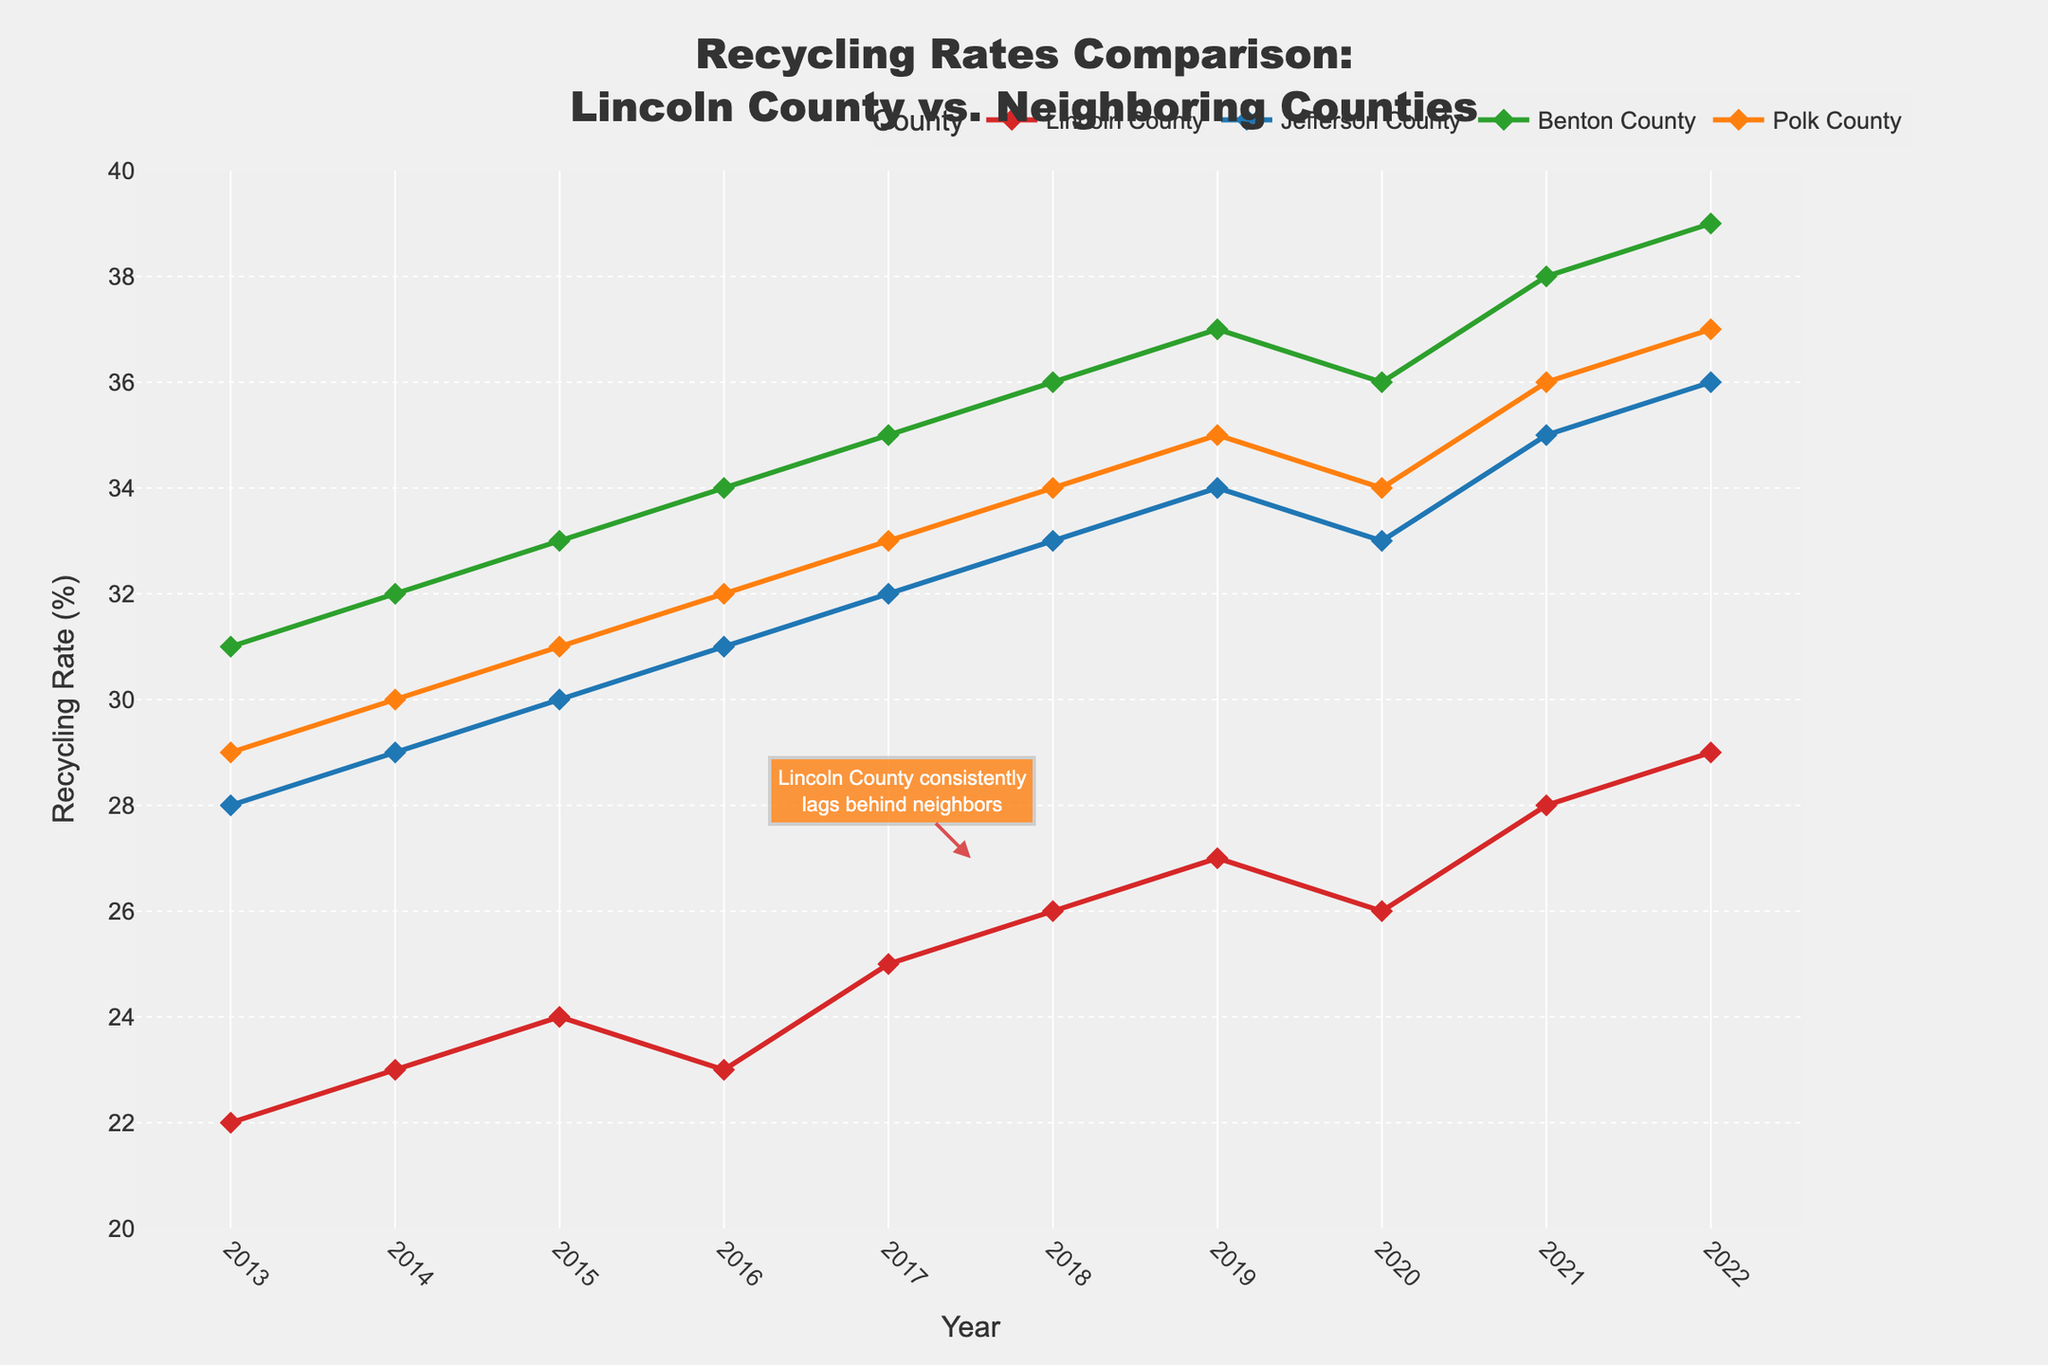Which county had the highest recycling rate in 2022? By examining the data for the year 2022 on the line chart, we can see that Benton County's line is at the highest point, indicating the highest recycling rate.
Answer: Benton County How much did Lincoln County's recycling rate increase from 2013 to 2022? From the line chart, Lincoln County's recycling rate in 2013 was 22%, and in 2022 it was 29%. The increase is calculated as 29% - 22% = 7%.
Answer: 7% Between 2019 and 2021, did any county show a decline in recycling rate? Analyzing the slopes of the lines between 2019 and 2021, only Lincoln County shows an initial drop from 2019 (27%) to 2020 (26%) before increasing again in 2021 (28%).
Answer: Lincoln County What is the average recycling rate of Benton County over the provided years? Summing the recycling rates of Benton County over all years: 31 + 32 + 33 + 34 + 35 + 36 + 37 + 36 + 38 + 39 = 351. The average is calculated by dividing by the number of years (10), giving 351 / 10 = 35.1%.
Answer: 35.1% Which county's recycling rate showed the most consistent increase over the years? By inspecting the slopes of all counties' lines, Jefferson County shows a gradual and consistent increase over the years without significant dips.
Answer: Jefferson County In which year did Lincoln County's recycling rate surpass 25%? Inspecting the line representing Lincoln County, we find it surpasses 25% by 2017, reaching 25%.
Answer: 2017 How does Polk County's recycling rate in 2020 compare to Lincoln County's rate in 2020? In 2020, Polk County's rate is 34%, while Lincoln County's rate is 26%. Therefore, Polk County's rate is higher by 34% - 26% = 8%.
Answer: Higher by 8% What is the total increase in recycling rates for Polk County from 2013 to 2022? From the chart, Polk County's rate in 2013 is 29% and in 2022 is 37%. The total increase is 37% - 29% = 8%.
Answer: 8% Which county had the smallest variation in recycling rates over the years? By examining the fluctuation of the lines, Jefferson County has the smallest variation with a consistent yearly increase and no abrupt changes.
Answer: Jefferson County 